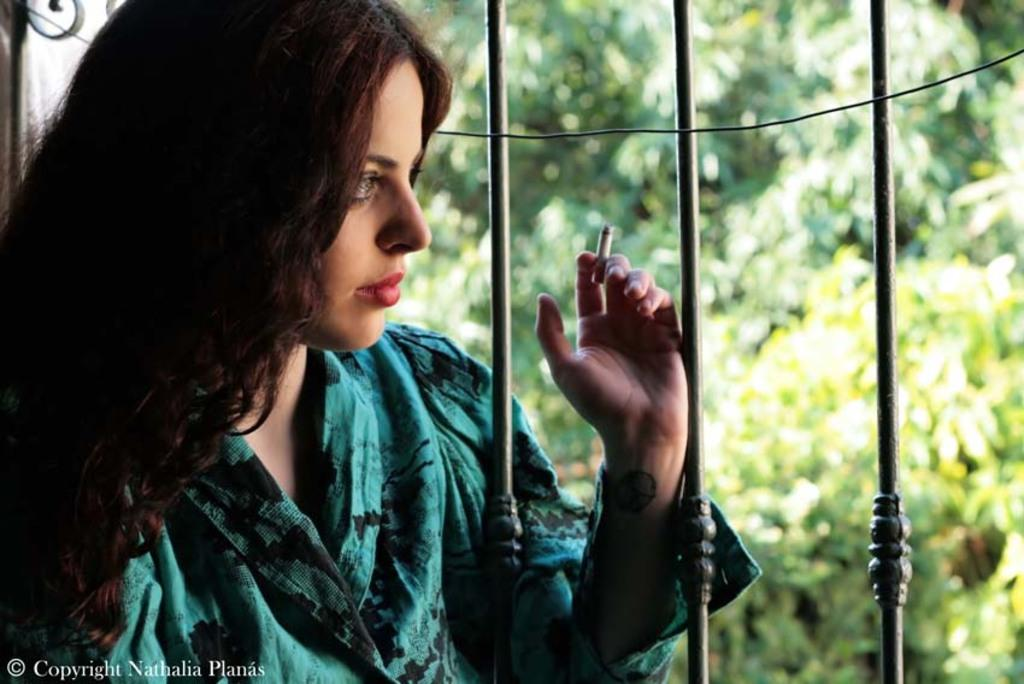Who is present in the image? There is a woman in the image. What is the woman holding in the image? The woman is holding a cigarette. What can be seen in the background of the image? There are grills and trees in the background of the image. Where is the zebra sitting on the sofa in the image? There is no zebra or sofa present in the image. What type of bread is being toasted on the grills in the background? There is no bread visible on the grills in the background of the image. 